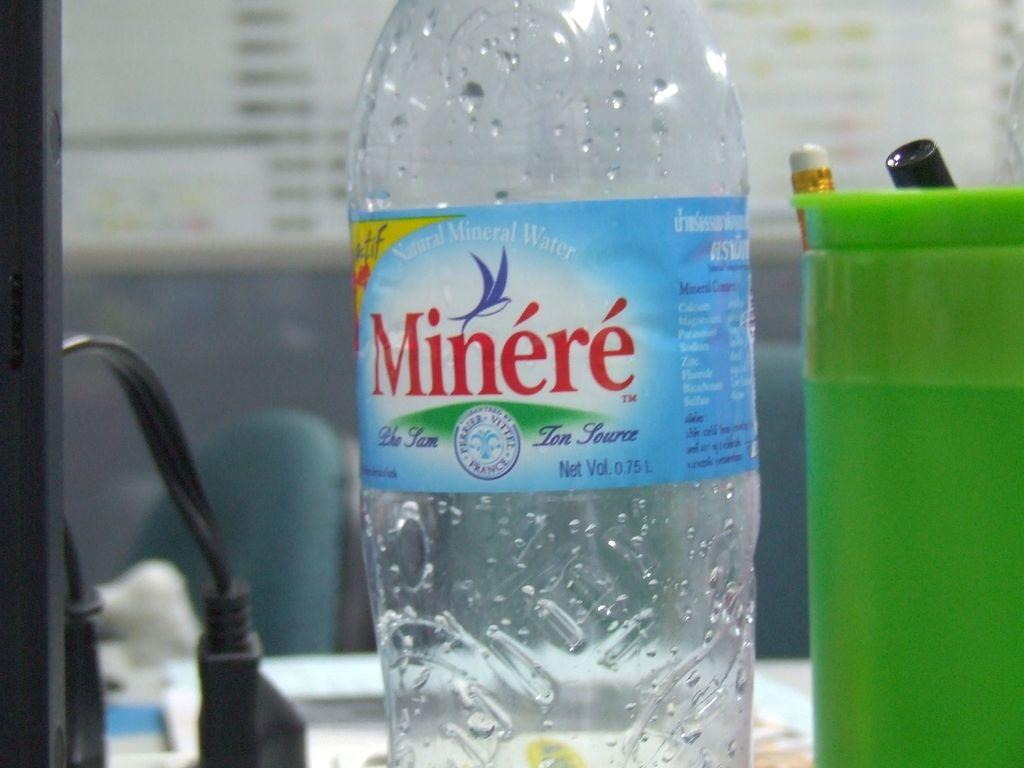<image>
Create a compact narrative representing the image presented. An empty bottle of Minere is on the counter. 